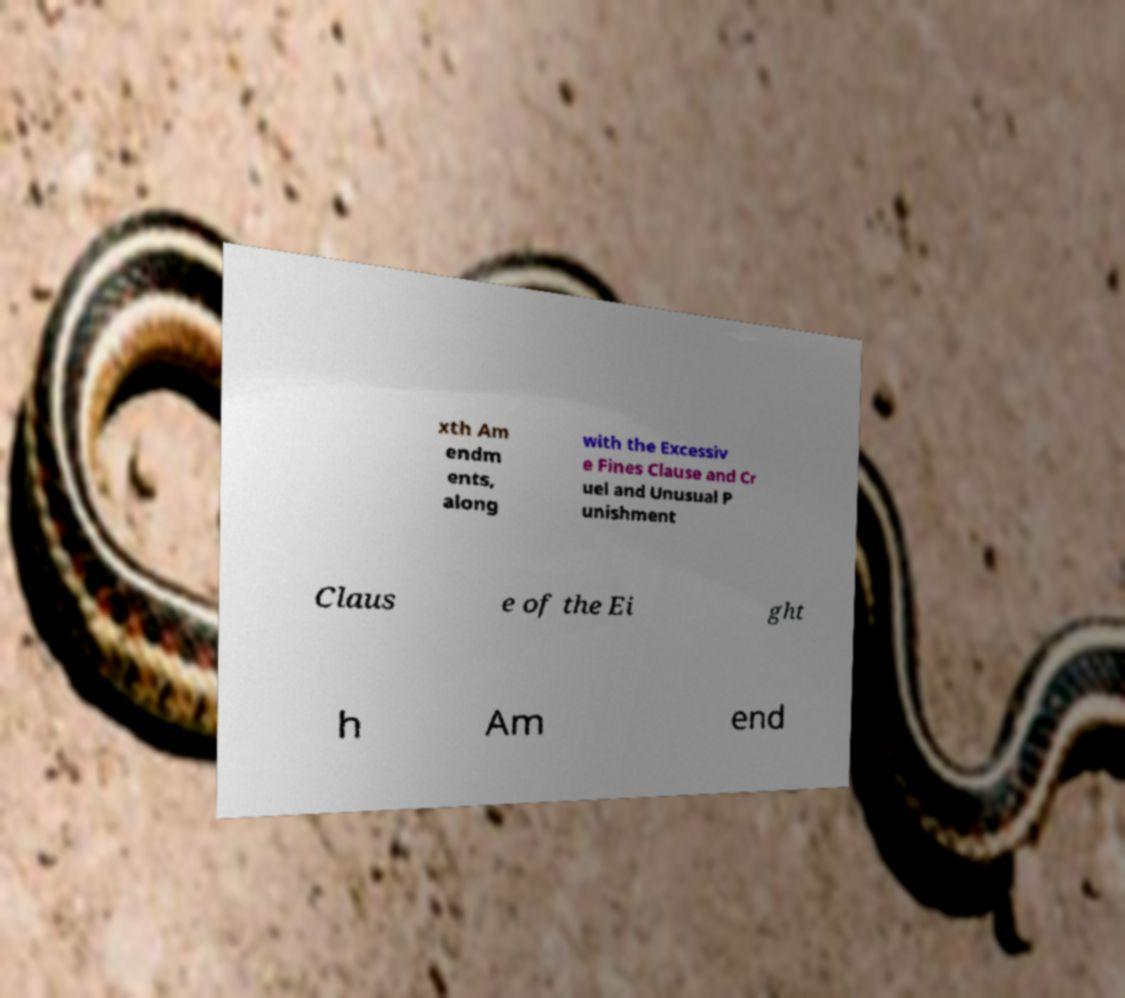There's text embedded in this image that I need extracted. Can you transcribe it verbatim? xth Am endm ents, along with the Excessiv e Fines Clause and Cr uel and Unusual P unishment Claus e of the Ei ght h Am end 